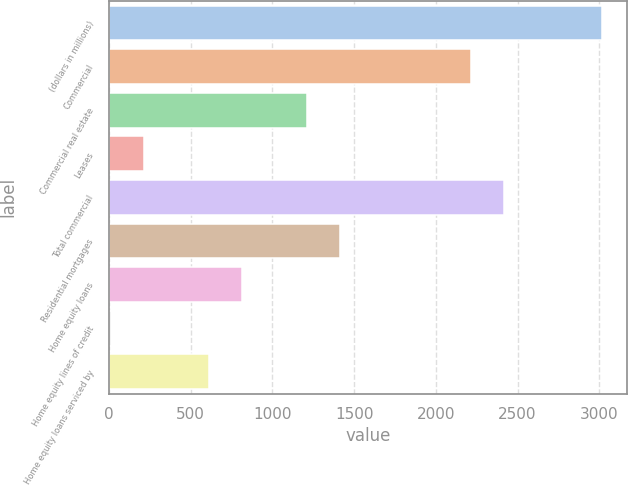Convert chart. <chart><loc_0><loc_0><loc_500><loc_500><bar_chart><fcel>(dollars in millions)<fcel>Commercial<fcel>Commercial real estate<fcel>Leases<fcel>Total commercial<fcel>Residential mortgages<fcel>Home equity loans<fcel>Home equity lines of credit<fcel>Home equity loans serviced by<nl><fcel>3017<fcel>2215.4<fcel>1213.4<fcel>211.4<fcel>2415.8<fcel>1413.8<fcel>812.6<fcel>11<fcel>612.2<nl></chart> 